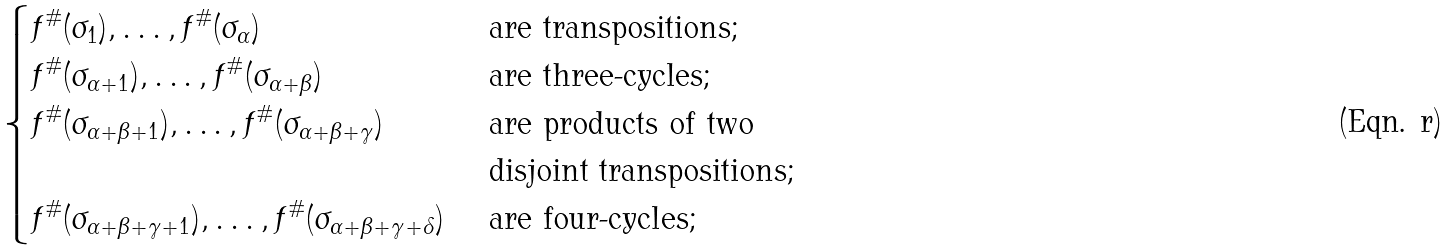<formula> <loc_0><loc_0><loc_500><loc_500>\begin{cases} f ^ { \# } ( \sigma _ { 1 } ) , \dots , f ^ { \# } ( \sigma _ { \alpha } ) & \text { are transpositions; } \\ f ^ { \# } ( \sigma _ { \alpha + 1 } ) , \dots , f ^ { \# } ( \sigma _ { \alpha + \beta } ) & \text { are three-cycles; } \\ f ^ { \# } ( \sigma _ { \alpha + \beta + 1 } ) , \dots , f ^ { \# } ( \sigma _ { \alpha + \beta + \gamma } ) & \text { are products of two } \\ & \text { disjoint transpositions; } \\ f ^ { \# } ( \sigma _ { \alpha + \beta + \gamma + 1 } ) , \dots , f ^ { \# } ( \sigma _ { \alpha + \beta + \gamma + \delta } ) & \text { are four-cycles; } \\ \end{cases}</formula> 